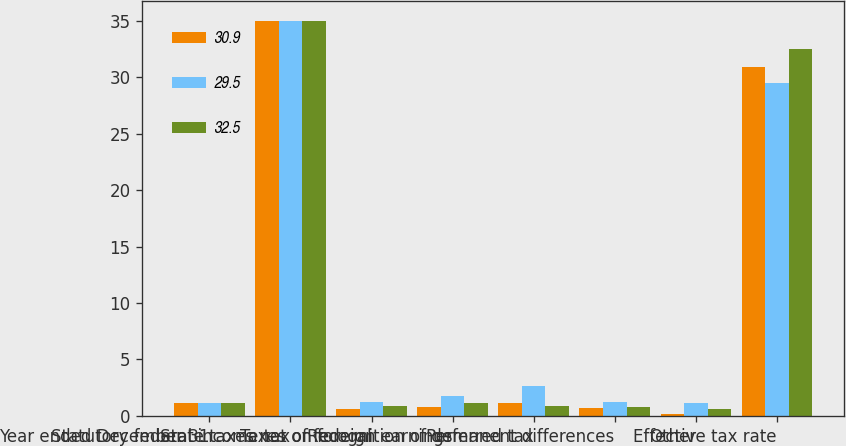<chart> <loc_0><loc_0><loc_500><loc_500><stacked_bar_chart><ecel><fcel>Year ended December 31<fcel>Statutory federal income tax<fcel>State taxes net of federal<fcel>Taxes on foreign earnings<fcel>Recognition of deferred tax<fcel>Permanent differences<fcel>Other<fcel>Effective tax rate<nl><fcel>30.9<fcel>1.1<fcel>35<fcel>0.6<fcel>0.8<fcel>1.1<fcel>0.7<fcel>0.2<fcel>30.9<nl><fcel>29.5<fcel>1.1<fcel>35<fcel>1.2<fcel>1.8<fcel>2.6<fcel>1.2<fcel>1.1<fcel>29.5<nl><fcel>32.5<fcel>1.1<fcel>35<fcel>0.9<fcel>1.1<fcel>0.9<fcel>0.8<fcel>0.6<fcel>32.5<nl></chart> 